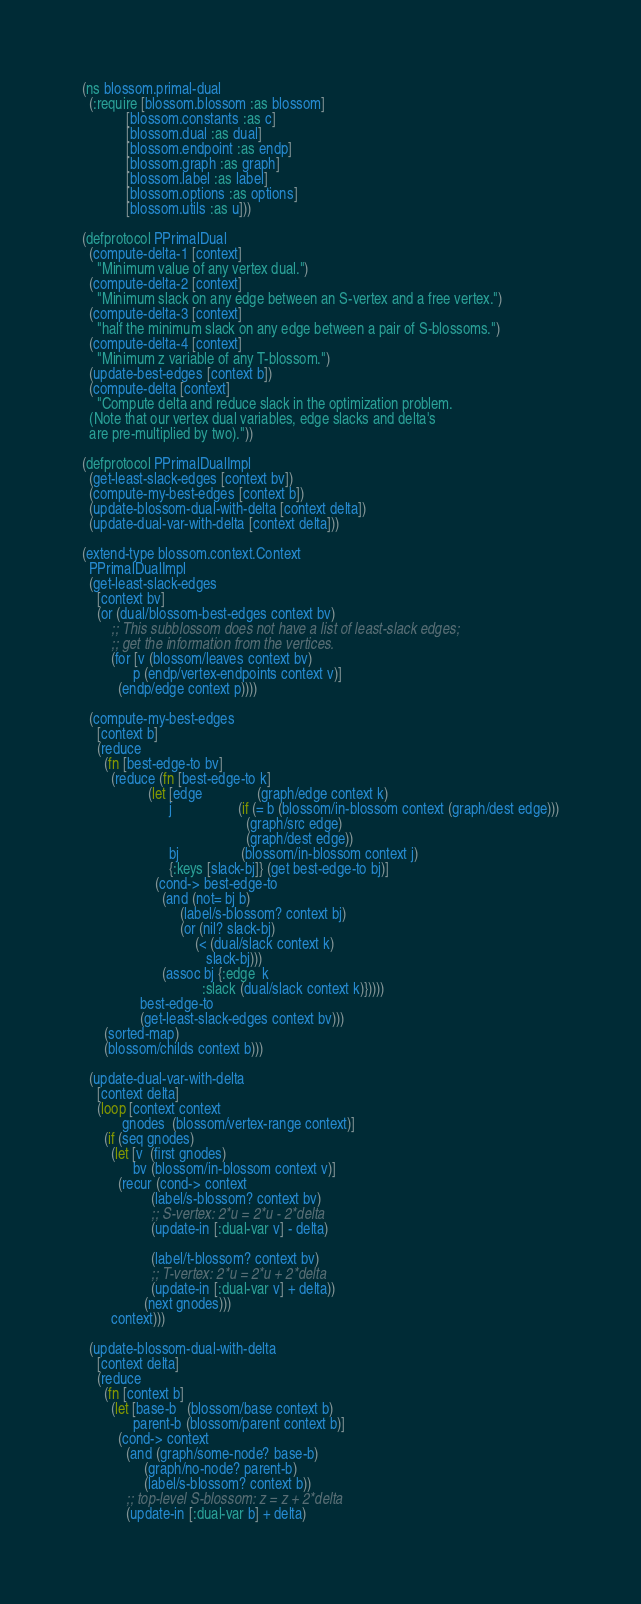Convert code to text. <code><loc_0><loc_0><loc_500><loc_500><_Clojure_>(ns blossom.primal-dual
  (:require [blossom.blossom :as blossom]
            [blossom.constants :as c]
            [blossom.dual :as dual]
            [blossom.endpoint :as endp]
            [blossom.graph :as graph]
            [blossom.label :as label]
            [blossom.options :as options]
            [blossom.utils :as u]))

(defprotocol PPrimalDual
  (compute-delta-1 [context]
    "Minimum value of any vertex dual.")
  (compute-delta-2 [context]
    "Minimum slack on any edge between an S-vertex and a free vertex.")
  (compute-delta-3 [context]
    "half the minimum slack on any edge between a pair of S-blossoms.")
  (compute-delta-4 [context]
    "Minimum z variable of any T-blossom.")
  (update-best-edges [context b])
  (compute-delta [context]
    "Compute delta and reduce slack in the optimization problem.
  (Note that our vertex dual variables, edge slacks and delta's
  are pre-multiplied by two)."))

(defprotocol PPrimalDualImpl
  (get-least-slack-edges [context bv])
  (compute-my-best-edges [context b])
  (update-blossom-dual-with-delta [context delta])
  (update-dual-var-with-delta [context delta]))

(extend-type blossom.context.Context
  PPrimalDualImpl
  (get-least-slack-edges
    [context bv]
    (or (dual/blossom-best-edges context bv)
        ;; This subblossom does not have a list of least-slack edges;
        ;; get the information from the vertices.
        (for [v (blossom/leaves context bv)
              p (endp/vertex-endpoints context v)]
          (endp/edge context p))))

  (compute-my-best-edges
    [context b]
    (reduce
      (fn [best-edge-to bv]
        (reduce (fn [best-edge-to k]
                  (let [edge               (graph/edge context k)
                        j                  (if (= b (blossom/in-blossom context (graph/dest edge)))
                                             (graph/src edge)
                                             (graph/dest edge))
                        bj                 (blossom/in-blossom context j)
                        {:keys [slack-bj]} (get best-edge-to bj)]
                    (cond-> best-edge-to
                      (and (not= bj b)
                           (label/s-blossom? context bj)
                           (or (nil? slack-bj)
                               (< (dual/slack context k)
                                  slack-bj)))
                      (assoc bj {:edge  k
                                 :slack (dual/slack context k)}))))
                best-edge-to
                (get-least-slack-edges context bv)))
      (sorted-map)
      (blossom/childs context b)))

  (update-dual-var-with-delta
    [context delta]
    (loop [context context
           gnodes  (blossom/vertex-range context)]
      (if (seq gnodes)
        (let [v  (first gnodes)
              bv (blossom/in-blossom context v)]
          (recur (cond-> context
                   (label/s-blossom? context bv)
                   ;; S-vertex: 2*u = 2*u - 2*delta
                   (update-in [:dual-var v] - delta)

                   (label/t-blossom? context bv)
                   ;; T-vertex: 2*u = 2*u + 2*delta
                   (update-in [:dual-var v] + delta))
                 (next gnodes)))
        context)))

  (update-blossom-dual-with-delta
    [context delta]
    (reduce
      (fn [context b]
        (let [base-b   (blossom/base context b)
              parent-b (blossom/parent context b)]
          (cond-> context
            (and (graph/some-node? base-b)
                 (graph/no-node? parent-b)
                 (label/s-blossom? context b))
            ;; top-level S-blossom: z = z + 2*delta
            (update-in [:dual-var b] + delta)
</code> 